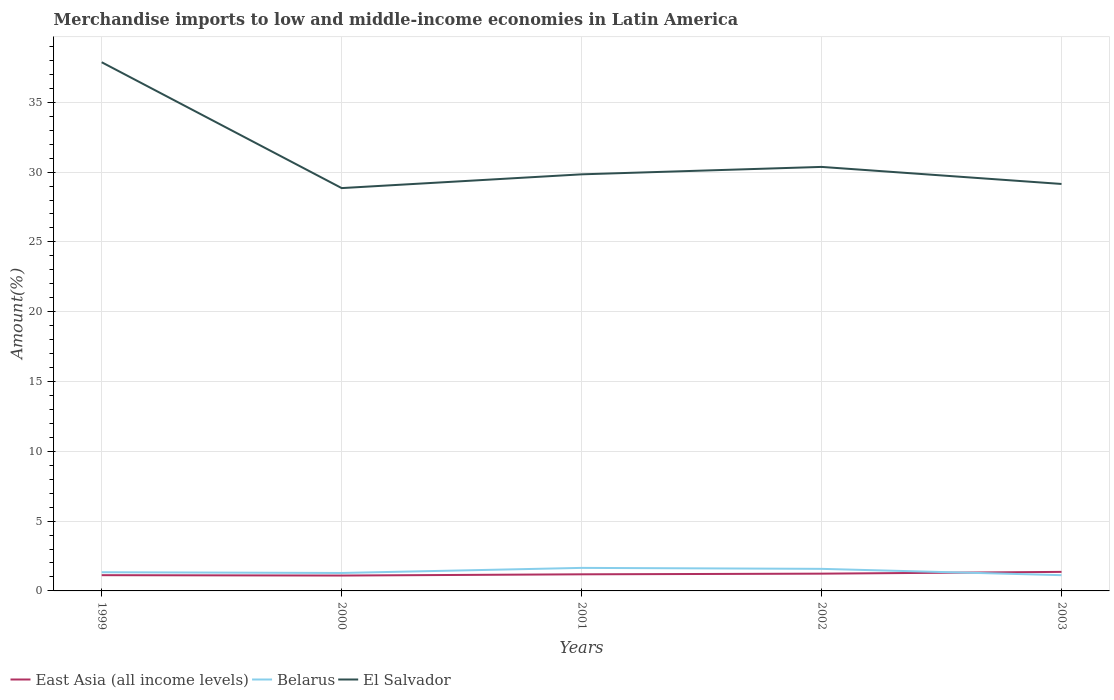How many different coloured lines are there?
Make the answer very short. 3. Is the number of lines equal to the number of legend labels?
Offer a terse response. Yes. Across all years, what is the maximum percentage of amount earned from merchandise imports in East Asia (all income levels)?
Ensure brevity in your answer.  1.1. In which year was the percentage of amount earned from merchandise imports in Belarus maximum?
Your answer should be very brief. 2003. What is the total percentage of amount earned from merchandise imports in East Asia (all income levels) in the graph?
Offer a very short reply. -0.05. What is the difference between the highest and the second highest percentage of amount earned from merchandise imports in Belarus?
Offer a terse response. 0.52. What is the difference between the highest and the lowest percentage of amount earned from merchandise imports in East Asia (all income levels)?
Your answer should be compact. 2. How many lines are there?
Your response must be concise. 3. Where does the legend appear in the graph?
Give a very brief answer. Bottom left. What is the title of the graph?
Offer a very short reply. Merchandise imports to low and middle-income economies in Latin America. What is the label or title of the X-axis?
Provide a succinct answer. Years. What is the label or title of the Y-axis?
Keep it short and to the point. Amount(%). What is the Amount(%) of East Asia (all income levels) in 1999?
Your response must be concise. 1.13. What is the Amount(%) in Belarus in 1999?
Provide a succinct answer. 1.34. What is the Amount(%) in El Salvador in 1999?
Your answer should be compact. 37.87. What is the Amount(%) of East Asia (all income levels) in 2000?
Provide a succinct answer. 1.1. What is the Amount(%) in Belarus in 2000?
Provide a short and direct response. 1.29. What is the Amount(%) in El Salvador in 2000?
Offer a terse response. 28.85. What is the Amount(%) of East Asia (all income levels) in 2001?
Make the answer very short. 1.19. What is the Amount(%) in Belarus in 2001?
Make the answer very short. 1.65. What is the Amount(%) in El Salvador in 2001?
Your answer should be compact. 29.84. What is the Amount(%) in East Asia (all income levels) in 2002?
Your answer should be very brief. 1.24. What is the Amount(%) of Belarus in 2002?
Your response must be concise. 1.58. What is the Amount(%) in El Salvador in 2002?
Your response must be concise. 30.37. What is the Amount(%) in East Asia (all income levels) in 2003?
Offer a terse response. 1.36. What is the Amount(%) in Belarus in 2003?
Provide a succinct answer. 1.13. What is the Amount(%) of El Salvador in 2003?
Provide a short and direct response. 29.15. Across all years, what is the maximum Amount(%) of East Asia (all income levels)?
Make the answer very short. 1.36. Across all years, what is the maximum Amount(%) of Belarus?
Your response must be concise. 1.65. Across all years, what is the maximum Amount(%) of El Salvador?
Give a very brief answer. 37.87. Across all years, what is the minimum Amount(%) of East Asia (all income levels)?
Give a very brief answer. 1.1. Across all years, what is the minimum Amount(%) of Belarus?
Make the answer very short. 1.13. Across all years, what is the minimum Amount(%) of El Salvador?
Your answer should be compact. 28.85. What is the total Amount(%) of East Asia (all income levels) in the graph?
Provide a succinct answer. 6.02. What is the total Amount(%) of Belarus in the graph?
Provide a short and direct response. 6.98. What is the total Amount(%) of El Salvador in the graph?
Your response must be concise. 156.09. What is the difference between the Amount(%) in East Asia (all income levels) in 1999 and that in 2000?
Provide a short and direct response. 0.03. What is the difference between the Amount(%) of Belarus in 1999 and that in 2000?
Keep it short and to the point. 0.05. What is the difference between the Amount(%) of El Salvador in 1999 and that in 2000?
Provide a succinct answer. 9.01. What is the difference between the Amount(%) in East Asia (all income levels) in 1999 and that in 2001?
Offer a terse response. -0.06. What is the difference between the Amount(%) in Belarus in 1999 and that in 2001?
Keep it short and to the point. -0.31. What is the difference between the Amount(%) in El Salvador in 1999 and that in 2001?
Offer a very short reply. 8.03. What is the difference between the Amount(%) of East Asia (all income levels) in 1999 and that in 2002?
Give a very brief answer. -0.11. What is the difference between the Amount(%) of Belarus in 1999 and that in 2002?
Your response must be concise. -0.24. What is the difference between the Amount(%) in El Salvador in 1999 and that in 2002?
Your answer should be compact. 7.5. What is the difference between the Amount(%) of East Asia (all income levels) in 1999 and that in 2003?
Your answer should be very brief. -0.24. What is the difference between the Amount(%) in Belarus in 1999 and that in 2003?
Give a very brief answer. 0.21. What is the difference between the Amount(%) of El Salvador in 1999 and that in 2003?
Keep it short and to the point. 8.72. What is the difference between the Amount(%) of East Asia (all income levels) in 2000 and that in 2001?
Offer a terse response. -0.09. What is the difference between the Amount(%) in Belarus in 2000 and that in 2001?
Make the answer very short. -0.36. What is the difference between the Amount(%) of El Salvador in 2000 and that in 2001?
Your response must be concise. -0.99. What is the difference between the Amount(%) of East Asia (all income levels) in 2000 and that in 2002?
Keep it short and to the point. -0.14. What is the difference between the Amount(%) in Belarus in 2000 and that in 2002?
Your answer should be compact. -0.29. What is the difference between the Amount(%) in El Salvador in 2000 and that in 2002?
Your answer should be very brief. -1.52. What is the difference between the Amount(%) in East Asia (all income levels) in 2000 and that in 2003?
Provide a succinct answer. -0.26. What is the difference between the Amount(%) of Belarus in 2000 and that in 2003?
Provide a succinct answer. 0.16. What is the difference between the Amount(%) of El Salvador in 2000 and that in 2003?
Ensure brevity in your answer.  -0.3. What is the difference between the Amount(%) of East Asia (all income levels) in 2001 and that in 2002?
Keep it short and to the point. -0.05. What is the difference between the Amount(%) in Belarus in 2001 and that in 2002?
Provide a succinct answer. 0.07. What is the difference between the Amount(%) of El Salvador in 2001 and that in 2002?
Provide a succinct answer. -0.53. What is the difference between the Amount(%) of East Asia (all income levels) in 2001 and that in 2003?
Provide a short and direct response. -0.17. What is the difference between the Amount(%) in Belarus in 2001 and that in 2003?
Offer a very short reply. 0.52. What is the difference between the Amount(%) in El Salvador in 2001 and that in 2003?
Keep it short and to the point. 0.69. What is the difference between the Amount(%) in East Asia (all income levels) in 2002 and that in 2003?
Your response must be concise. -0.13. What is the difference between the Amount(%) in Belarus in 2002 and that in 2003?
Your response must be concise. 0.45. What is the difference between the Amount(%) in El Salvador in 2002 and that in 2003?
Keep it short and to the point. 1.22. What is the difference between the Amount(%) in East Asia (all income levels) in 1999 and the Amount(%) in Belarus in 2000?
Provide a short and direct response. -0.16. What is the difference between the Amount(%) of East Asia (all income levels) in 1999 and the Amount(%) of El Salvador in 2000?
Provide a succinct answer. -27.73. What is the difference between the Amount(%) of Belarus in 1999 and the Amount(%) of El Salvador in 2000?
Ensure brevity in your answer.  -27.52. What is the difference between the Amount(%) of East Asia (all income levels) in 1999 and the Amount(%) of Belarus in 2001?
Your answer should be very brief. -0.52. What is the difference between the Amount(%) of East Asia (all income levels) in 1999 and the Amount(%) of El Salvador in 2001?
Your answer should be compact. -28.71. What is the difference between the Amount(%) in Belarus in 1999 and the Amount(%) in El Salvador in 2001?
Your answer should be compact. -28.5. What is the difference between the Amount(%) in East Asia (all income levels) in 1999 and the Amount(%) in Belarus in 2002?
Make the answer very short. -0.45. What is the difference between the Amount(%) in East Asia (all income levels) in 1999 and the Amount(%) in El Salvador in 2002?
Make the answer very short. -29.24. What is the difference between the Amount(%) in Belarus in 1999 and the Amount(%) in El Salvador in 2002?
Keep it short and to the point. -29.03. What is the difference between the Amount(%) in East Asia (all income levels) in 1999 and the Amount(%) in Belarus in 2003?
Offer a terse response. -0. What is the difference between the Amount(%) in East Asia (all income levels) in 1999 and the Amount(%) in El Salvador in 2003?
Make the answer very short. -28.02. What is the difference between the Amount(%) of Belarus in 1999 and the Amount(%) of El Salvador in 2003?
Offer a very short reply. -27.81. What is the difference between the Amount(%) of East Asia (all income levels) in 2000 and the Amount(%) of Belarus in 2001?
Keep it short and to the point. -0.55. What is the difference between the Amount(%) in East Asia (all income levels) in 2000 and the Amount(%) in El Salvador in 2001?
Offer a terse response. -28.74. What is the difference between the Amount(%) in Belarus in 2000 and the Amount(%) in El Salvador in 2001?
Offer a very short reply. -28.55. What is the difference between the Amount(%) of East Asia (all income levels) in 2000 and the Amount(%) of Belarus in 2002?
Keep it short and to the point. -0.48. What is the difference between the Amount(%) in East Asia (all income levels) in 2000 and the Amount(%) in El Salvador in 2002?
Make the answer very short. -29.27. What is the difference between the Amount(%) in Belarus in 2000 and the Amount(%) in El Salvador in 2002?
Provide a succinct answer. -29.09. What is the difference between the Amount(%) in East Asia (all income levels) in 2000 and the Amount(%) in Belarus in 2003?
Offer a terse response. -0.03. What is the difference between the Amount(%) in East Asia (all income levels) in 2000 and the Amount(%) in El Salvador in 2003?
Keep it short and to the point. -28.05. What is the difference between the Amount(%) in Belarus in 2000 and the Amount(%) in El Salvador in 2003?
Keep it short and to the point. -27.86. What is the difference between the Amount(%) of East Asia (all income levels) in 2001 and the Amount(%) of Belarus in 2002?
Offer a terse response. -0.39. What is the difference between the Amount(%) in East Asia (all income levels) in 2001 and the Amount(%) in El Salvador in 2002?
Your answer should be compact. -29.18. What is the difference between the Amount(%) in Belarus in 2001 and the Amount(%) in El Salvador in 2002?
Your answer should be very brief. -28.72. What is the difference between the Amount(%) of East Asia (all income levels) in 2001 and the Amount(%) of Belarus in 2003?
Keep it short and to the point. 0.06. What is the difference between the Amount(%) of East Asia (all income levels) in 2001 and the Amount(%) of El Salvador in 2003?
Ensure brevity in your answer.  -27.96. What is the difference between the Amount(%) of Belarus in 2001 and the Amount(%) of El Salvador in 2003?
Offer a terse response. -27.5. What is the difference between the Amount(%) of East Asia (all income levels) in 2002 and the Amount(%) of Belarus in 2003?
Provide a short and direct response. 0.11. What is the difference between the Amount(%) in East Asia (all income levels) in 2002 and the Amount(%) in El Salvador in 2003?
Your response must be concise. -27.91. What is the difference between the Amount(%) in Belarus in 2002 and the Amount(%) in El Salvador in 2003?
Provide a short and direct response. -27.57. What is the average Amount(%) of East Asia (all income levels) per year?
Provide a short and direct response. 1.2. What is the average Amount(%) of Belarus per year?
Your answer should be very brief. 1.4. What is the average Amount(%) in El Salvador per year?
Provide a short and direct response. 31.22. In the year 1999, what is the difference between the Amount(%) in East Asia (all income levels) and Amount(%) in Belarus?
Provide a short and direct response. -0.21. In the year 1999, what is the difference between the Amount(%) in East Asia (all income levels) and Amount(%) in El Salvador?
Ensure brevity in your answer.  -36.74. In the year 1999, what is the difference between the Amount(%) in Belarus and Amount(%) in El Salvador?
Provide a succinct answer. -36.53. In the year 2000, what is the difference between the Amount(%) of East Asia (all income levels) and Amount(%) of Belarus?
Give a very brief answer. -0.18. In the year 2000, what is the difference between the Amount(%) in East Asia (all income levels) and Amount(%) in El Salvador?
Offer a terse response. -27.75. In the year 2000, what is the difference between the Amount(%) of Belarus and Amount(%) of El Salvador?
Give a very brief answer. -27.57. In the year 2001, what is the difference between the Amount(%) in East Asia (all income levels) and Amount(%) in Belarus?
Make the answer very short. -0.46. In the year 2001, what is the difference between the Amount(%) of East Asia (all income levels) and Amount(%) of El Salvador?
Make the answer very short. -28.65. In the year 2001, what is the difference between the Amount(%) in Belarus and Amount(%) in El Salvador?
Provide a succinct answer. -28.19. In the year 2002, what is the difference between the Amount(%) in East Asia (all income levels) and Amount(%) in Belarus?
Your answer should be very brief. -0.34. In the year 2002, what is the difference between the Amount(%) of East Asia (all income levels) and Amount(%) of El Salvador?
Your answer should be compact. -29.14. In the year 2002, what is the difference between the Amount(%) in Belarus and Amount(%) in El Salvador?
Give a very brief answer. -28.79. In the year 2003, what is the difference between the Amount(%) of East Asia (all income levels) and Amount(%) of Belarus?
Keep it short and to the point. 0.24. In the year 2003, what is the difference between the Amount(%) in East Asia (all income levels) and Amount(%) in El Salvador?
Your answer should be very brief. -27.79. In the year 2003, what is the difference between the Amount(%) in Belarus and Amount(%) in El Salvador?
Offer a terse response. -28.02. What is the ratio of the Amount(%) of East Asia (all income levels) in 1999 to that in 2000?
Your response must be concise. 1.02. What is the ratio of the Amount(%) in Belarus in 1999 to that in 2000?
Your response must be concise. 1.04. What is the ratio of the Amount(%) in El Salvador in 1999 to that in 2000?
Your response must be concise. 1.31. What is the ratio of the Amount(%) of East Asia (all income levels) in 1999 to that in 2001?
Your answer should be compact. 0.95. What is the ratio of the Amount(%) of Belarus in 1999 to that in 2001?
Your answer should be compact. 0.81. What is the ratio of the Amount(%) in El Salvador in 1999 to that in 2001?
Ensure brevity in your answer.  1.27. What is the ratio of the Amount(%) of East Asia (all income levels) in 1999 to that in 2002?
Offer a terse response. 0.91. What is the ratio of the Amount(%) of Belarus in 1999 to that in 2002?
Ensure brevity in your answer.  0.85. What is the ratio of the Amount(%) in El Salvador in 1999 to that in 2002?
Offer a very short reply. 1.25. What is the ratio of the Amount(%) of East Asia (all income levels) in 1999 to that in 2003?
Offer a terse response. 0.83. What is the ratio of the Amount(%) of Belarus in 1999 to that in 2003?
Your answer should be compact. 1.19. What is the ratio of the Amount(%) in El Salvador in 1999 to that in 2003?
Offer a very short reply. 1.3. What is the ratio of the Amount(%) in East Asia (all income levels) in 2000 to that in 2001?
Provide a short and direct response. 0.93. What is the ratio of the Amount(%) in Belarus in 2000 to that in 2001?
Offer a terse response. 0.78. What is the ratio of the Amount(%) of El Salvador in 2000 to that in 2001?
Your answer should be very brief. 0.97. What is the ratio of the Amount(%) of East Asia (all income levels) in 2000 to that in 2002?
Provide a succinct answer. 0.89. What is the ratio of the Amount(%) of Belarus in 2000 to that in 2002?
Offer a very short reply. 0.81. What is the ratio of the Amount(%) of East Asia (all income levels) in 2000 to that in 2003?
Ensure brevity in your answer.  0.81. What is the ratio of the Amount(%) in Belarus in 2000 to that in 2003?
Make the answer very short. 1.14. What is the ratio of the Amount(%) of El Salvador in 2000 to that in 2003?
Make the answer very short. 0.99. What is the ratio of the Amount(%) in East Asia (all income levels) in 2001 to that in 2002?
Keep it short and to the point. 0.96. What is the ratio of the Amount(%) in Belarus in 2001 to that in 2002?
Provide a succinct answer. 1.04. What is the ratio of the Amount(%) of El Salvador in 2001 to that in 2002?
Your response must be concise. 0.98. What is the ratio of the Amount(%) of East Asia (all income levels) in 2001 to that in 2003?
Make the answer very short. 0.87. What is the ratio of the Amount(%) in Belarus in 2001 to that in 2003?
Ensure brevity in your answer.  1.46. What is the ratio of the Amount(%) of El Salvador in 2001 to that in 2003?
Make the answer very short. 1.02. What is the ratio of the Amount(%) in East Asia (all income levels) in 2002 to that in 2003?
Your answer should be very brief. 0.91. What is the ratio of the Amount(%) in Belarus in 2002 to that in 2003?
Provide a short and direct response. 1.4. What is the ratio of the Amount(%) in El Salvador in 2002 to that in 2003?
Ensure brevity in your answer.  1.04. What is the difference between the highest and the second highest Amount(%) of East Asia (all income levels)?
Provide a succinct answer. 0.13. What is the difference between the highest and the second highest Amount(%) in Belarus?
Offer a terse response. 0.07. What is the difference between the highest and the second highest Amount(%) of El Salvador?
Offer a terse response. 7.5. What is the difference between the highest and the lowest Amount(%) of East Asia (all income levels)?
Offer a very short reply. 0.26. What is the difference between the highest and the lowest Amount(%) in Belarus?
Offer a terse response. 0.52. What is the difference between the highest and the lowest Amount(%) of El Salvador?
Provide a succinct answer. 9.01. 